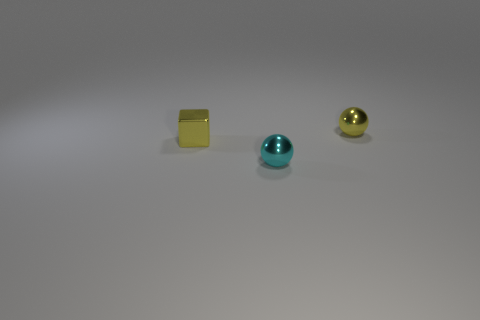Add 2 small yellow metallic objects. How many objects exist? 5 Subtract all blocks. How many objects are left? 2 Add 3 metallic blocks. How many metallic blocks are left? 4 Add 3 tiny objects. How many tiny objects exist? 6 Subtract 0 green cubes. How many objects are left? 3 Subtract all small metallic balls. Subtract all small cyan metal spheres. How many objects are left? 0 